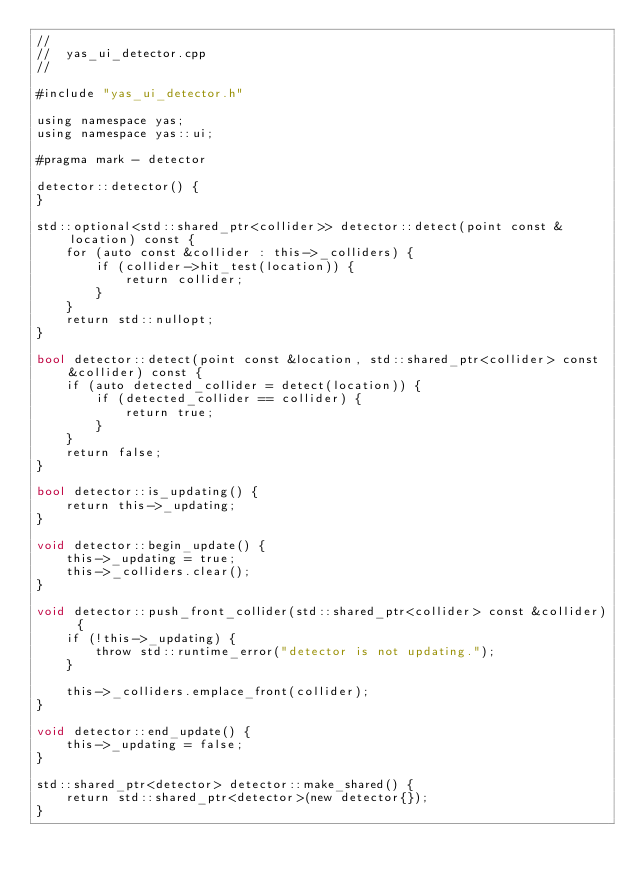<code> <loc_0><loc_0><loc_500><loc_500><_ObjectiveC_>//
//  yas_ui_detector.cpp
//

#include "yas_ui_detector.h"

using namespace yas;
using namespace yas::ui;

#pragma mark - detector

detector::detector() {
}

std::optional<std::shared_ptr<collider>> detector::detect(point const &location) const {
    for (auto const &collider : this->_colliders) {
        if (collider->hit_test(location)) {
            return collider;
        }
    }
    return std::nullopt;
}

bool detector::detect(point const &location, std::shared_ptr<collider> const &collider) const {
    if (auto detected_collider = detect(location)) {
        if (detected_collider == collider) {
            return true;
        }
    }
    return false;
}

bool detector::is_updating() {
    return this->_updating;
}

void detector::begin_update() {
    this->_updating = true;
    this->_colliders.clear();
}

void detector::push_front_collider(std::shared_ptr<collider> const &collider) {
    if (!this->_updating) {
        throw std::runtime_error("detector is not updating.");
    }

    this->_colliders.emplace_front(collider);
}

void detector::end_update() {
    this->_updating = false;
}

std::shared_ptr<detector> detector::make_shared() {
    return std::shared_ptr<detector>(new detector{});
}
</code> 